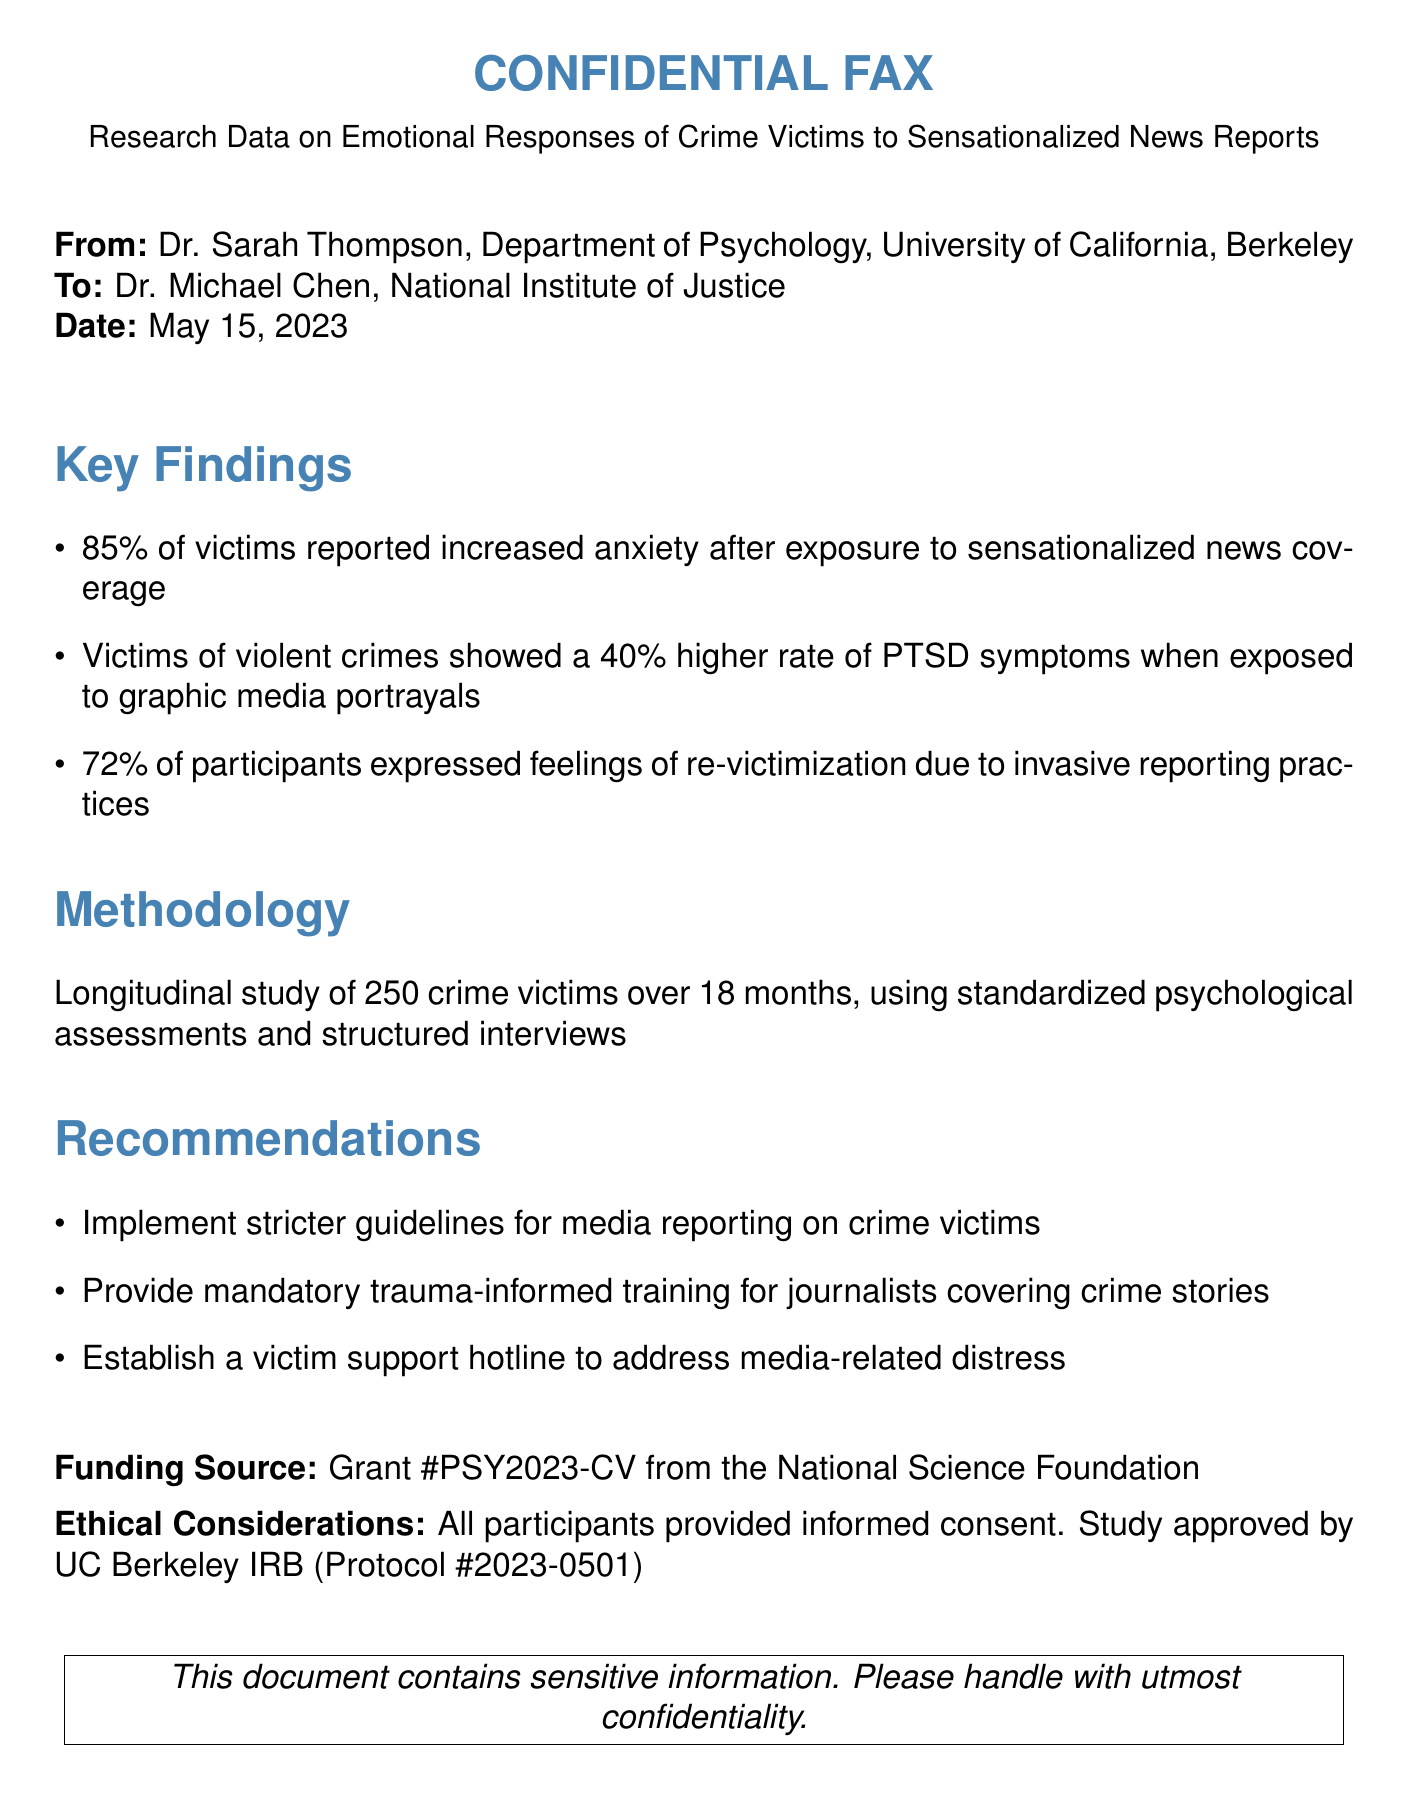what percentage of victims reported increased anxiety? The document states that 85% of victims reported increased anxiety after exposure to sensationalized news coverage.
Answer: 85% what is the primary finding regarding PTSD symptoms? The study found that victims of violent crimes showed a 40% higher rate of PTSD symptoms when exposed to graphic media portrayals.
Answer: 40% how many participants were involved in the study? The document mentions a longitudinal study of 250 crime victims.
Answer: 250 what guidelines are recommended for media reporting? One of the recommendations is to implement stricter guidelines for media reporting on crime victims.
Answer: stricter guidelines who funded the research? The funding source is Grant #PSY2023-CV from the National Science Foundation.
Answer: Grant #PSY2023-CV what was the duration of the study? The study was conducted over 18 months.
Answer: 18 months what feelings did 72% of participants express? The document states that 72% of participants expressed feelings of re-victimization due to invasive reporting practices.
Answer: re-victimization when was the fax sent? The fax was sent on May 15, 2023.
Answer: May 15, 2023 what ethical approval did the study receive? The study was approved by UC Berkeley IRB, Protocol #2023-0501.
Answer: Protocol #2023-0501 